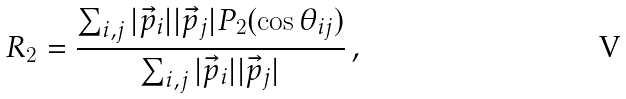<formula> <loc_0><loc_0><loc_500><loc_500>R _ { 2 } = \frac { \sum _ { i , j } | \vec { p } _ { i } | | \vec { p } _ { j } | P _ { 2 } ( \cos \theta _ { i j } ) } { \sum _ { i , j } | \vec { p } _ { i } | | \vec { p } _ { j } | } \, ,</formula> 